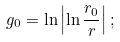Convert formula to latex. <formula><loc_0><loc_0><loc_500><loc_500>g _ { 0 } = \ln \left | \ln \frac { r _ { 0 } } { r } \right | ;</formula> 